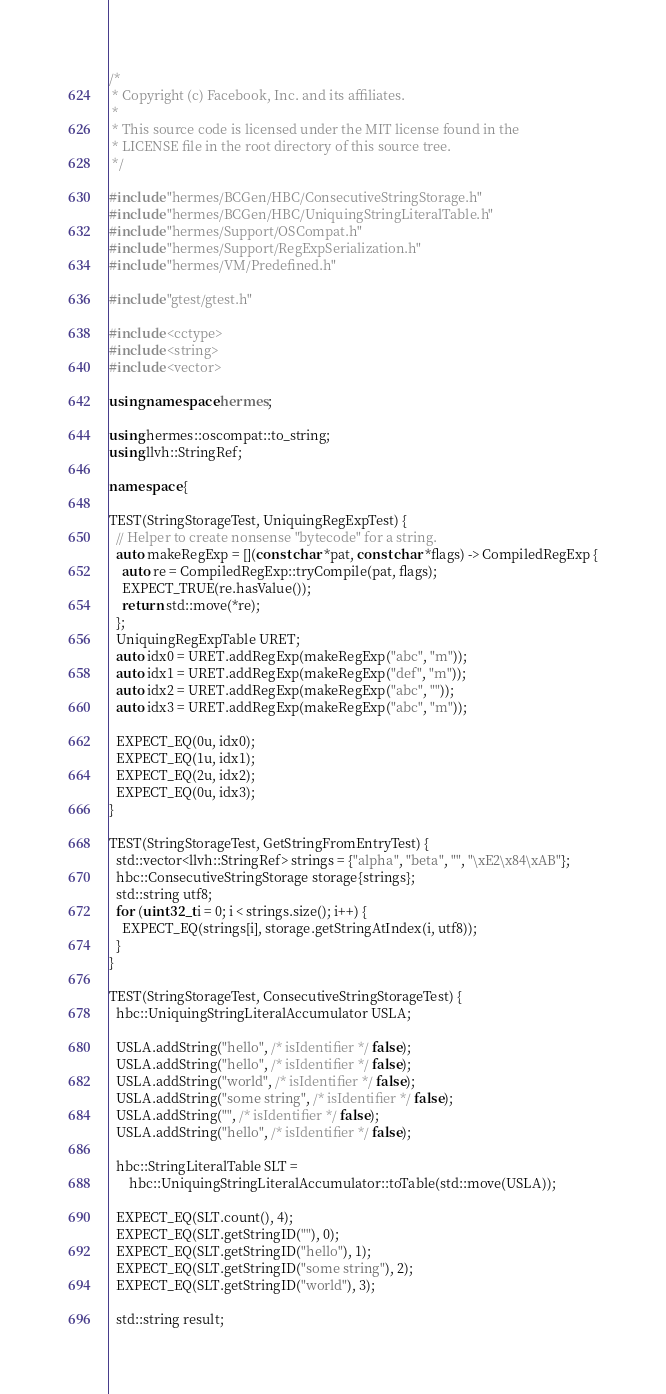Convert code to text. <code><loc_0><loc_0><loc_500><loc_500><_C++_>/*
 * Copyright (c) Facebook, Inc. and its affiliates.
 *
 * This source code is licensed under the MIT license found in the
 * LICENSE file in the root directory of this source tree.
 */

#include "hermes/BCGen/HBC/ConsecutiveStringStorage.h"
#include "hermes/BCGen/HBC/UniquingStringLiteralTable.h"
#include "hermes/Support/OSCompat.h"
#include "hermes/Support/RegExpSerialization.h"
#include "hermes/VM/Predefined.h"

#include "gtest/gtest.h"

#include <cctype>
#include <string>
#include <vector>

using namespace hermes;

using hermes::oscompat::to_string;
using llvh::StringRef;

namespace {

TEST(StringStorageTest, UniquingRegExpTest) {
  // Helper to create nonsense "bytecode" for a string.
  auto makeRegExp = [](const char *pat, const char *flags) -> CompiledRegExp {
    auto re = CompiledRegExp::tryCompile(pat, flags);
    EXPECT_TRUE(re.hasValue());
    return std::move(*re);
  };
  UniquingRegExpTable URET;
  auto idx0 = URET.addRegExp(makeRegExp("abc", "m"));
  auto idx1 = URET.addRegExp(makeRegExp("def", "m"));
  auto idx2 = URET.addRegExp(makeRegExp("abc", ""));
  auto idx3 = URET.addRegExp(makeRegExp("abc", "m"));

  EXPECT_EQ(0u, idx0);
  EXPECT_EQ(1u, idx1);
  EXPECT_EQ(2u, idx2);
  EXPECT_EQ(0u, idx3);
}

TEST(StringStorageTest, GetStringFromEntryTest) {
  std::vector<llvh::StringRef> strings = {"alpha", "beta", "", "\xE2\x84\xAB"};
  hbc::ConsecutiveStringStorage storage{strings};
  std::string utf8;
  for (uint32_t i = 0; i < strings.size(); i++) {
    EXPECT_EQ(strings[i], storage.getStringAtIndex(i, utf8));
  }
}

TEST(StringStorageTest, ConsecutiveStringStorageTest) {
  hbc::UniquingStringLiteralAccumulator USLA;

  USLA.addString("hello", /* isIdentifier */ false);
  USLA.addString("hello", /* isIdentifier */ false);
  USLA.addString("world", /* isIdentifier */ false);
  USLA.addString("some string", /* isIdentifier */ false);
  USLA.addString("", /* isIdentifier */ false);
  USLA.addString("hello", /* isIdentifier */ false);

  hbc::StringLiteralTable SLT =
      hbc::UniquingStringLiteralAccumulator::toTable(std::move(USLA));

  EXPECT_EQ(SLT.count(), 4);
  EXPECT_EQ(SLT.getStringID(""), 0);
  EXPECT_EQ(SLT.getStringID("hello"), 1);
  EXPECT_EQ(SLT.getStringID("some string"), 2);
  EXPECT_EQ(SLT.getStringID("world"), 3);

  std::string result;
</code> 